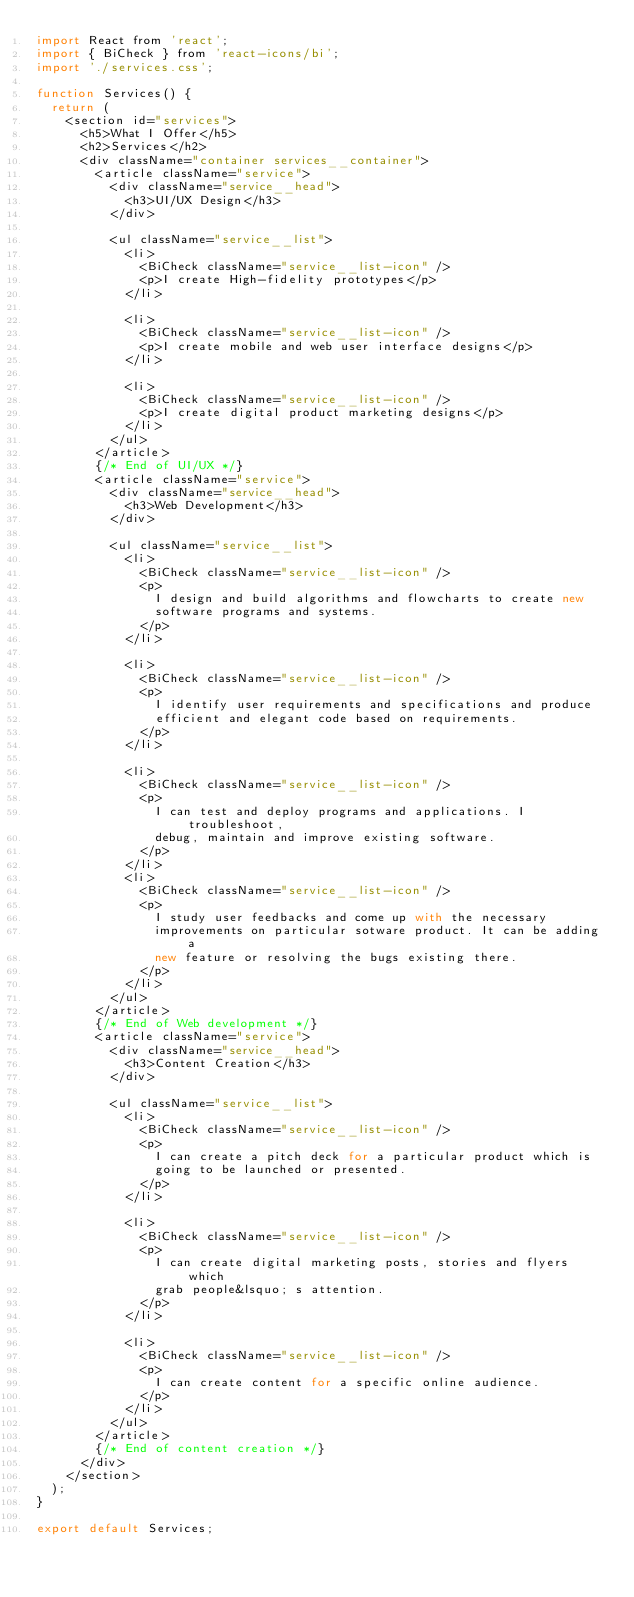Convert code to text. <code><loc_0><loc_0><loc_500><loc_500><_JavaScript_>import React from 'react';
import { BiCheck } from 'react-icons/bi';
import './services.css';

function Services() {
  return (
    <section id="services">
      <h5>What I Offer</h5>
      <h2>Services</h2>
      <div className="container services__container">
        <article className="service">
          <div className="service__head">
            <h3>UI/UX Design</h3>
          </div>

          <ul className="service__list">
            <li>
              <BiCheck className="service__list-icon" />
              <p>I create High-fidelity prototypes</p>
            </li>

            <li>
              <BiCheck className="service__list-icon" />
              <p>I create mobile and web user interface designs</p>
            </li>

            <li>
              <BiCheck className="service__list-icon" />
              <p>I create digital product marketing designs</p>
            </li>
          </ul>
        </article>
        {/* End of UI/UX */}
        <article className="service">
          <div className="service__head">
            <h3>Web Development</h3>
          </div>

          <ul className="service__list">
            <li>
              <BiCheck className="service__list-icon" />
              <p>
                I design and build algorithms and flowcharts to create new
                software programs and systems.
              </p>
            </li>

            <li>
              <BiCheck className="service__list-icon" />
              <p>
                I identify user requirements and specifications and produce
                efficient and elegant code based on requirements.
              </p>
            </li>

            <li>
              <BiCheck className="service__list-icon" />
              <p>
                I can test and deploy programs and applications. I troubleshoot,
                debug, maintain and improve existing software.
              </p>
            </li>
            <li>
              <BiCheck className="service__list-icon" />
              <p>
                I study user feedbacks and come up with the necessary
                improvements on particular sotware product. It can be adding a
                new feature or resolving the bugs existing there.
              </p>
            </li>
          </ul>
        </article>
        {/* End of Web development */}
        <article className="service">
          <div className="service__head">
            <h3>Content Creation</h3>
          </div>

          <ul className="service__list">
            <li>
              <BiCheck className="service__list-icon" />
              <p>
                I can create a pitch deck for a particular product which is
                going to be launched or presented.
              </p>
            </li>

            <li>
              <BiCheck className="service__list-icon" />
              <p>
                I can create digital marketing posts, stories and flyers which
                grab people&lsquo; s attention.
              </p>
            </li>

            <li>
              <BiCheck className="service__list-icon" />
              <p>
                I can create content for a specific online audience.
              </p>
            </li>
          </ul>
        </article>
        {/* End of content creation */}
      </div>
    </section>
  );
}

export default Services;
</code> 